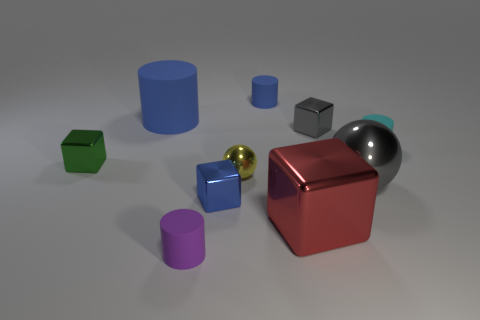The matte object that is the same color as the large matte cylinder is what shape?
Your response must be concise. Cylinder. There is a object behind the big blue thing; is it the same color as the large cylinder?
Keep it short and to the point. Yes. What material is the tiny cylinder that is the same color as the big rubber object?
Make the answer very short. Rubber. Are there any tiny matte objects that have the same color as the big metallic sphere?
Ensure brevity in your answer.  No. Does the blue shiny thing have the same shape as the red thing left of the gray metallic block?
Keep it short and to the point. Yes. Are there any small red cylinders made of the same material as the green cube?
Offer a very short reply. No. Are there any small objects that are right of the blue cylinder right of the tiny blue object in front of the tiny gray metallic thing?
Give a very brief answer. Yes. How many other objects are the same shape as the tiny blue matte thing?
Offer a very short reply. 3. There is a small block that is to the right of the blue matte object that is on the right side of the tiny matte cylinder in front of the large red shiny object; what is its color?
Provide a succinct answer. Gray. What number of small cyan rubber objects are there?
Offer a very short reply. 1. 